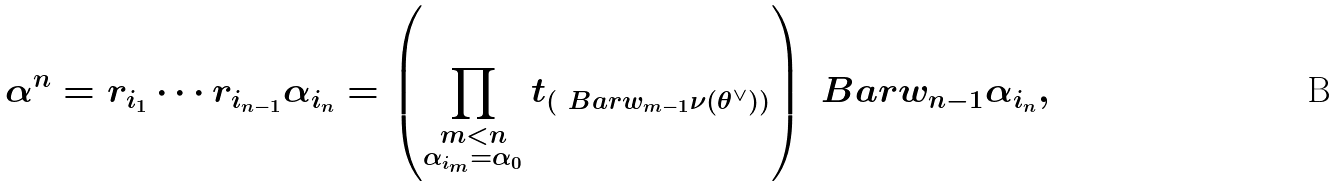<formula> <loc_0><loc_0><loc_500><loc_500>\alpha ^ { n } = r _ { i _ { 1 } } \cdots r _ { i _ { n - 1 } } \alpha _ { i _ { n } } = \left ( \prod _ { \substack { m < n \\ \alpha _ { i _ { m } } = \alpha _ { 0 } } } t _ { ( \ B a r { w } _ { m - 1 } \nu ( \theta ^ { \vee } ) ) } \right ) \ B a r { w } _ { n - 1 } \alpha _ { i _ { n } } ,</formula> 